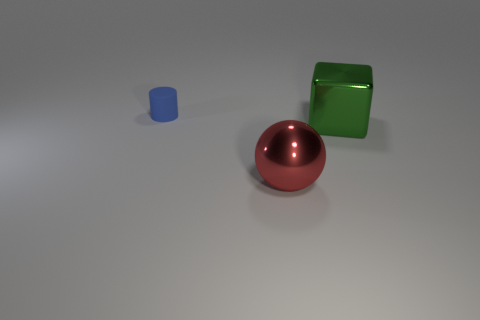Are there an equal number of big shiny objects right of the green block and small blue shiny cylinders?
Ensure brevity in your answer.  Yes. How many large red things are left of the metal thing that is behind the large thing in front of the large green cube?
Offer a very short reply. 1. What color is the rubber cylinder to the left of the metal ball?
Provide a succinct answer. Blue. What material is the object that is right of the tiny cylinder and to the left of the metallic cube?
Give a very brief answer. Metal. There is a large metal thing that is behind the metal sphere; how many big red shiny spheres are behind it?
Provide a succinct answer. 0. What is the shape of the blue thing?
Provide a succinct answer. Cylinder. There is a large object that is the same material as the green block; what is its shape?
Offer a very short reply. Sphere. Do the large metal object that is to the left of the block and the rubber thing have the same shape?
Your answer should be very brief. No. The big metal thing that is on the right side of the large red metallic thing has what shape?
Keep it short and to the point. Cube. What number of other things have the same size as the rubber object?
Provide a short and direct response. 0. 